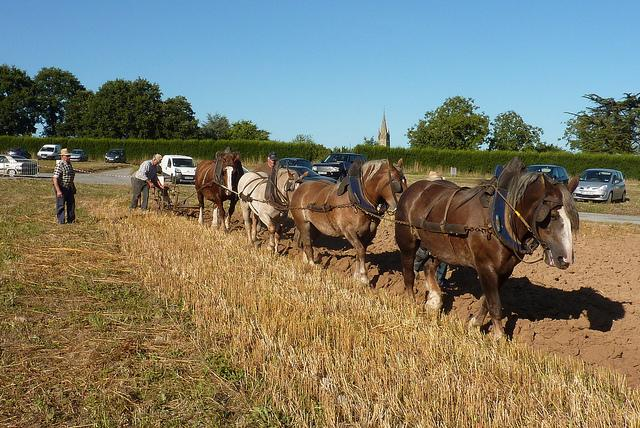Why are horses eyes covered?

Choices:
A) superstition
B) insects
C) confusion
D) style insects 